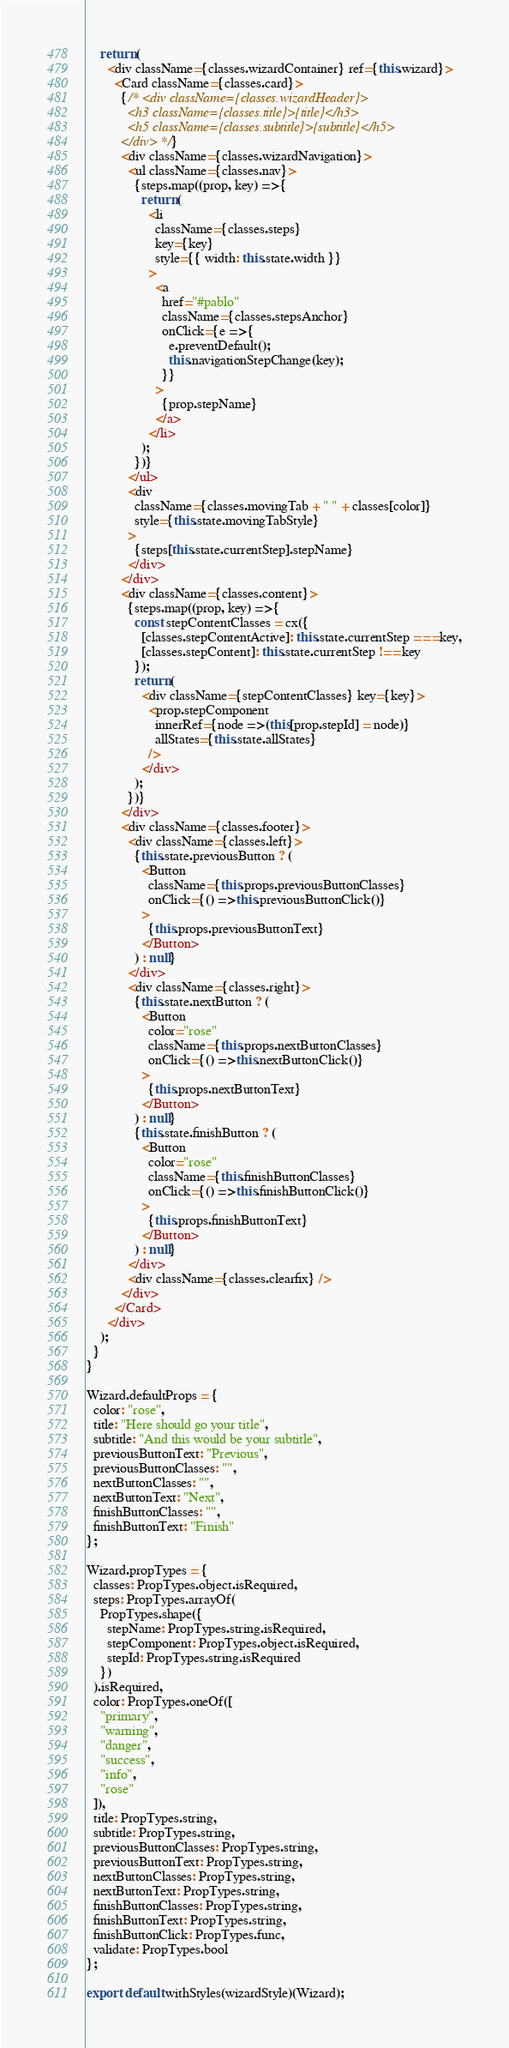<code> <loc_0><loc_0><loc_500><loc_500><_JavaScript_>    return (
      <div className={classes.wizardContainer} ref={this.wizard}>
        <Card className={classes.card}>
          {/* <div className={classes.wizardHeader}>
            <h3 className={classes.title}>{title}</h3>
            <h5 className={classes.subtitle}>{subtitle}</h5>
          </div> */}
          <div className={classes.wizardNavigation}>
            <ul className={classes.nav}>
              {steps.map((prop, key) => {
                return (
                  <li
                    className={classes.steps}
                    key={key}
                    style={{ width: this.state.width }}
                  >
                    <a
                      href="#pablo"
                      className={classes.stepsAnchor}
                      onClick={e => {
                        e.preventDefault();
                        this.navigationStepChange(key);
                      }}
                    >
                      {prop.stepName}
                    </a>
                  </li>
                );
              })}
            </ul>
            <div
              className={classes.movingTab + " " + classes[color]}
              style={this.state.movingTabStyle}
            >
              {steps[this.state.currentStep].stepName}
            </div>
          </div>
          <div className={classes.content}>
            {steps.map((prop, key) => {
              const stepContentClasses = cx({
                [classes.stepContentActive]: this.state.currentStep === key,
                [classes.stepContent]: this.state.currentStep !== key
              });
              return (
                <div className={stepContentClasses} key={key}>
                  <prop.stepComponent
                    innerRef={node => (this[prop.stepId] = node)}
                    allStates={this.state.allStates}
                  />
                </div>
              );
            })}
          </div>
          <div className={classes.footer}>
            <div className={classes.left}>
              {this.state.previousButton ? (
                <Button
                  className={this.props.previousButtonClasses}
                  onClick={() => this.previousButtonClick()}
                >
                  {this.props.previousButtonText}
                </Button>
              ) : null}
            </div>
            <div className={classes.right}>
              {this.state.nextButton ? (
                <Button
                  color="rose"
                  className={this.props.nextButtonClasses}
                  onClick={() => this.nextButtonClick()}
                >
                  {this.props.nextButtonText}
                </Button>
              ) : null}
              {this.state.finishButton ? (
                <Button
                  color="rose"
                  className={this.finishButtonClasses}
                  onClick={() => this.finishButtonClick()}
                >
                  {this.props.finishButtonText}
                </Button>
              ) : null}
            </div>
            <div className={classes.clearfix} />
          </div>
        </Card>
      </div>
    );
  }
}

Wizard.defaultProps = {
  color: "rose",
  title: "Here should go your title",
  subtitle: "And this would be your subtitle",
  previousButtonText: "Previous",
  previousButtonClasses: "",
  nextButtonClasses: "",
  nextButtonText: "Next",
  finishButtonClasses: "",
  finishButtonText: "Finish"
};

Wizard.propTypes = {
  classes: PropTypes.object.isRequired,
  steps: PropTypes.arrayOf(
    PropTypes.shape({
      stepName: PropTypes.string.isRequired,
      stepComponent: PropTypes.object.isRequired,
      stepId: PropTypes.string.isRequired
    })
  ).isRequired,
  color: PropTypes.oneOf([
    "primary",
    "warning",
    "danger",
    "success",
    "info",
    "rose"
  ]),
  title: PropTypes.string,
  subtitle: PropTypes.string,
  previousButtonClasses: PropTypes.string,
  previousButtonText: PropTypes.string,
  nextButtonClasses: PropTypes.string,
  nextButtonText: PropTypes.string,
  finishButtonClasses: PropTypes.string,
  finishButtonText: PropTypes.string,
  finishButtonClick: PropTypes.func,
  validate: PropTypes.bool
};

export default withStyles(wizardStyle)(Wizard);
</code> 